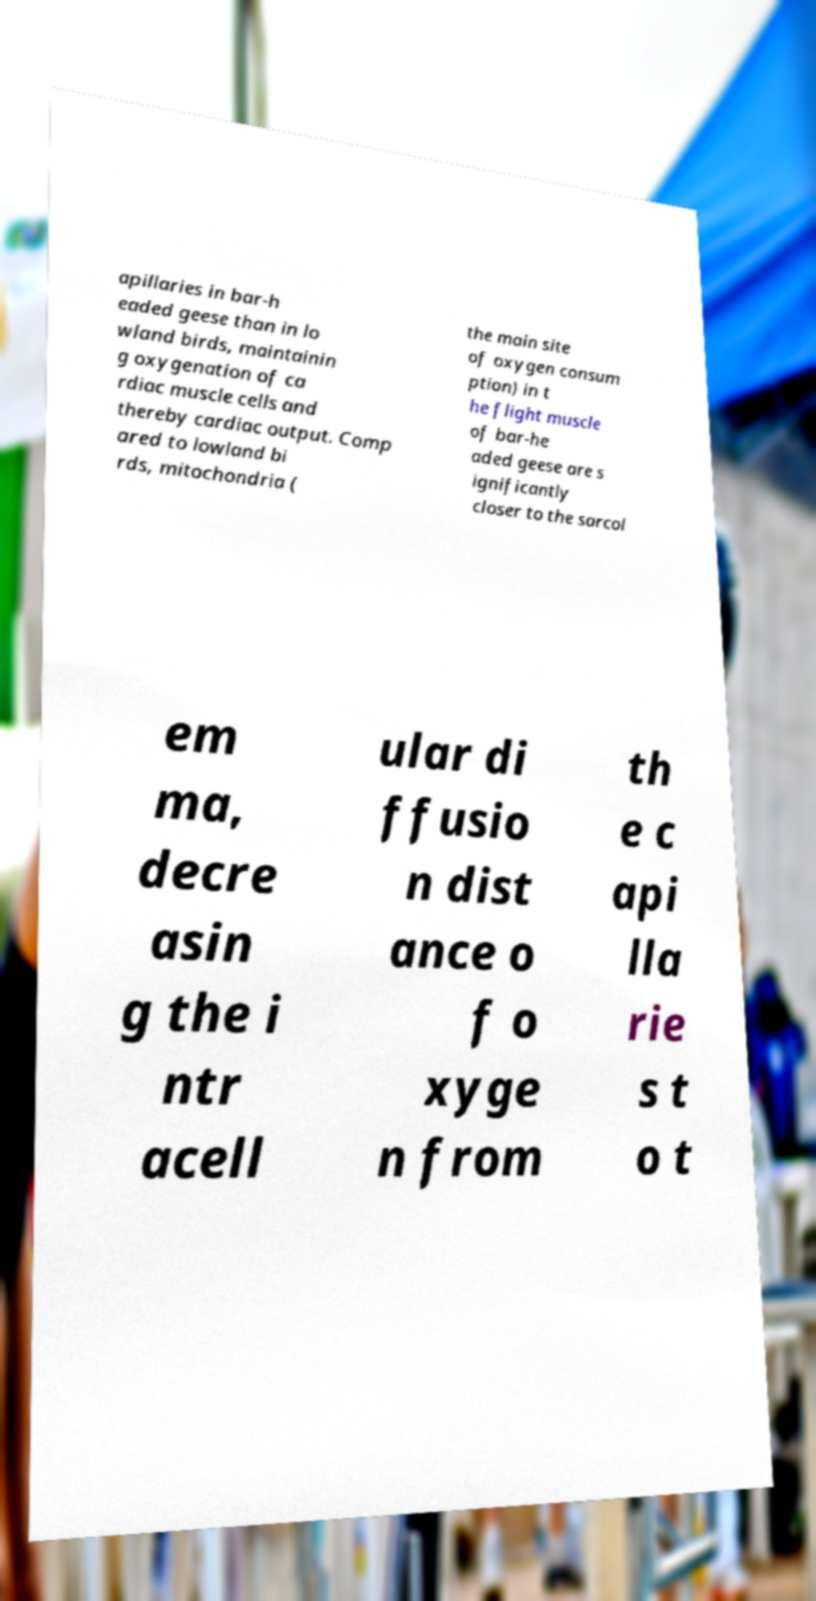What messages or text are displayed in this image? I need them in a readable, typed format. apillaries in bar-h eaded geese than in lo wland birds, maintainin g oxygenation of ca rdiac muscle cells and thereby cardiac output. Comp ared to lowland bi rds, mitochondria ( the main site of oxygen consum ption) in t he flight muscle of bar-he aded geese are s ignificantly closer to the sarcol em ma, decre asin g the i ntr acell ular di ffusio n dist ance o f o xyge n from th e c api lla rie s t o t 